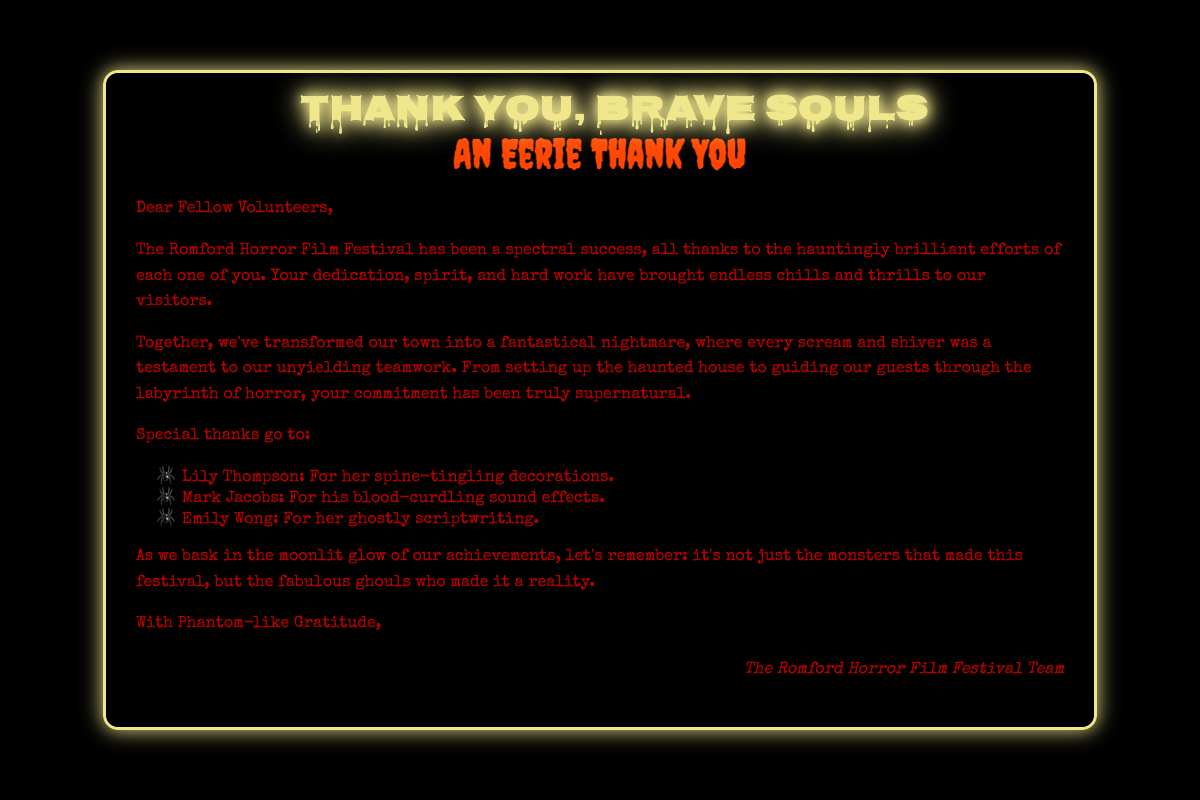What is the title of the card? The title of the card is presented prominently at the top of the content section.
Answer: An Eerie Thank You Who is the card addressed to? The greeting begins by addressing the recipients directly.
Answer: Fellow Volunteers What is one of the decorations credited to Lily Thompson? The specific contribution is mentioned in a list of special thanks.
Answer: Spine-tingling decorations What color is the text in the document? The text color is mentioned in the styling section of the document.
Answer: #b30000 What is described as a "spectral success"? The card acknowledges the overall impact of the event based on the volunteers' efforts.
Answer: The Romford Horror Film Festival Which design element glows in the dark? The document describes specific visual elements with glowing features.
Answer: Glow-in-the-dark elements Who contributed to the sound effects? The document contains a specific mention of a volunteer's contribution to sound.
Answer: Mark Jacobs What type of festival is being celebrated? The event type is identified in the introductory paragraph of the card.
Answer: Horror Film Festival What is the tone of gratitude in the conclusion? The closing line expresses appreciation in a unique way pertinent to the theme.
Answer: Phantom-like Gratitude 